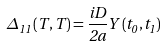<formula> <loc_0><loc_0><loc_500><loc_500>\Delta _ { 1 1 } \left ( T , T \right ) = \frac { i D } { 2 a } Y \left ( t _ { 0 } , t _ { 1 } \right )</formula> 